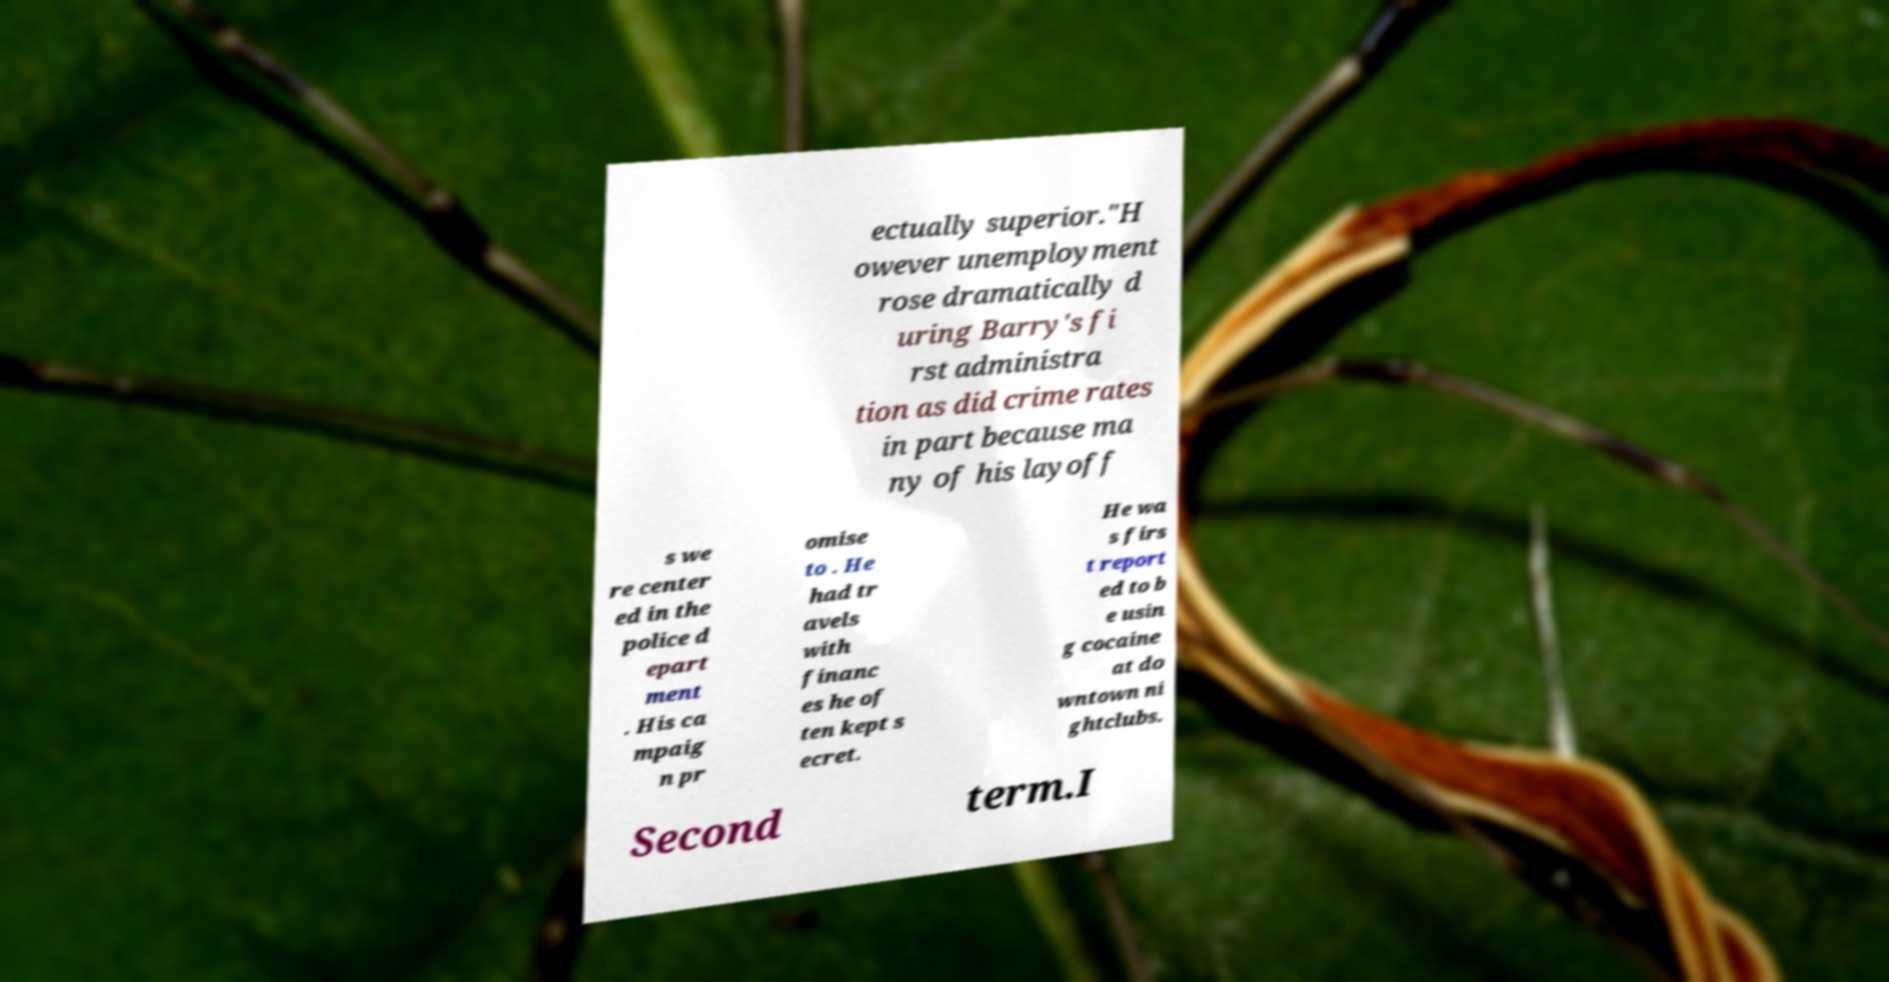Could you assist in decoding the text presented in this image and type it out clearly? ectually superior."H owever unemployment rose dramatically d uring Barry's fi rst administra tion as did crime rates in part because ma ny of his layoff s we re center ed in the police d epart ment . His ca mpaig n pr omise to . He had tr avels with financ es he of ten kept s ecret. He wa s firs t report ed to b e usin g cocaine at do wntown ni ghtclubs. Second term.I 